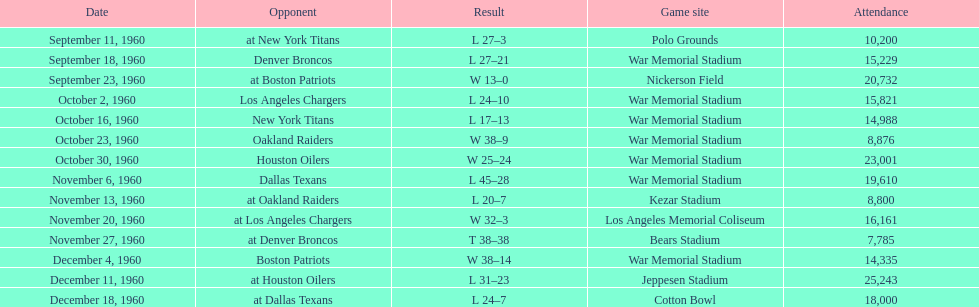How many times was war memorial stadium the game site? 6. 